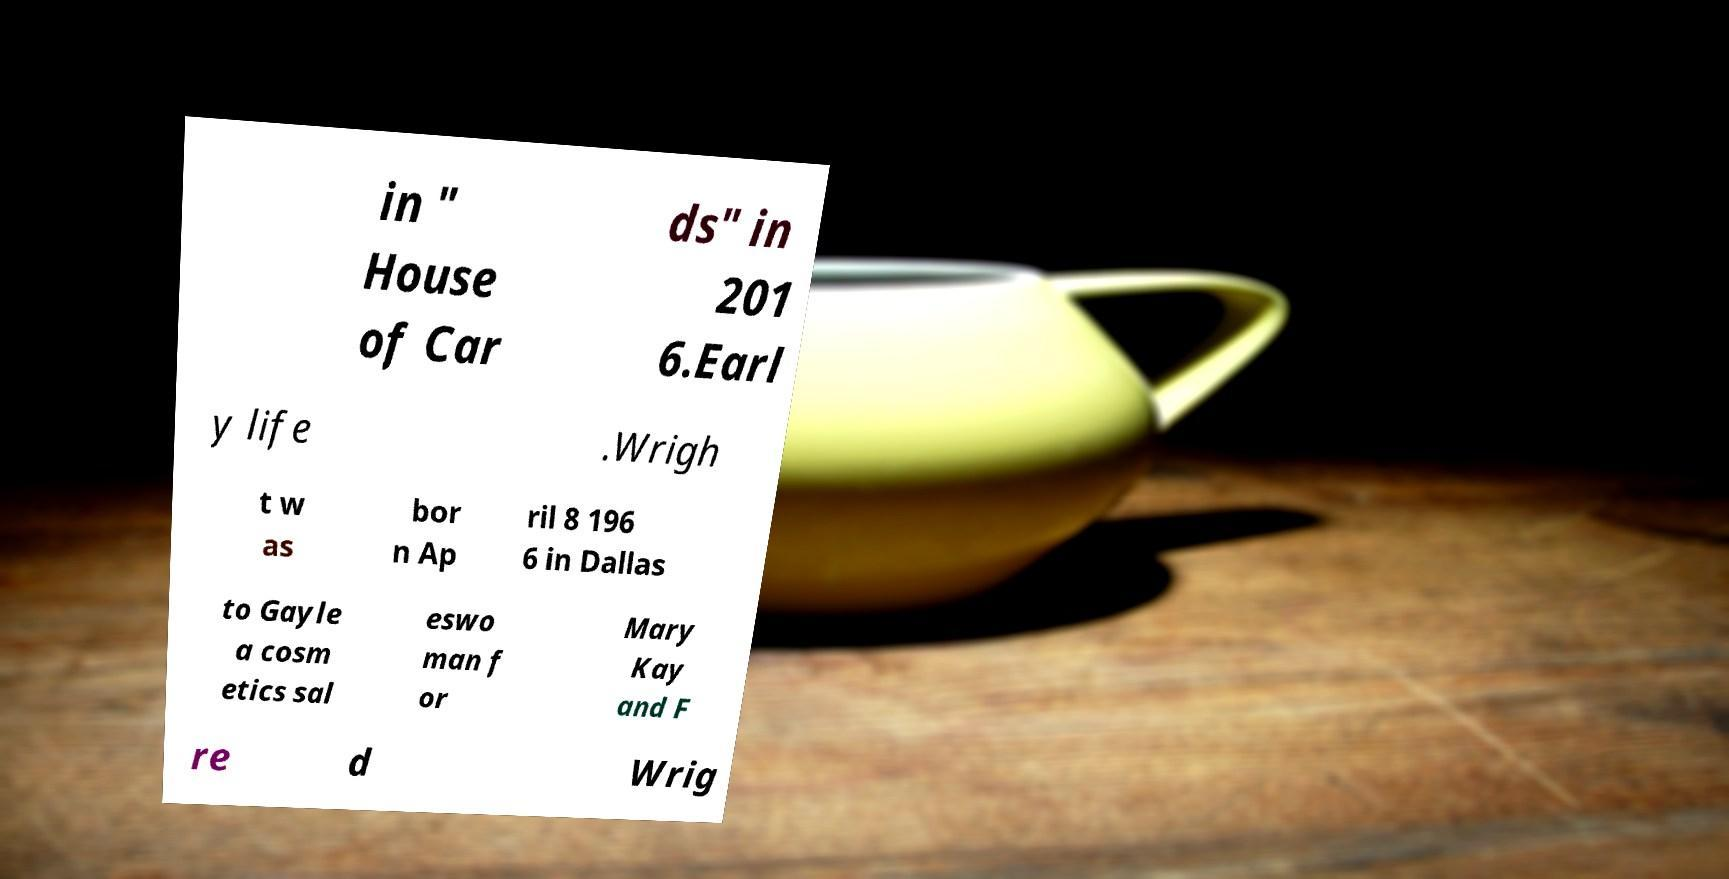Could you extract and type out the text from this image? in " House of Car ds" in 201 6.Earl y life .Wrigh t w as bor n Ap ril 8 196 6 in Dallas to Gayle a cosm etics sal eswo man f or Mary Kay and F re d Wrig 